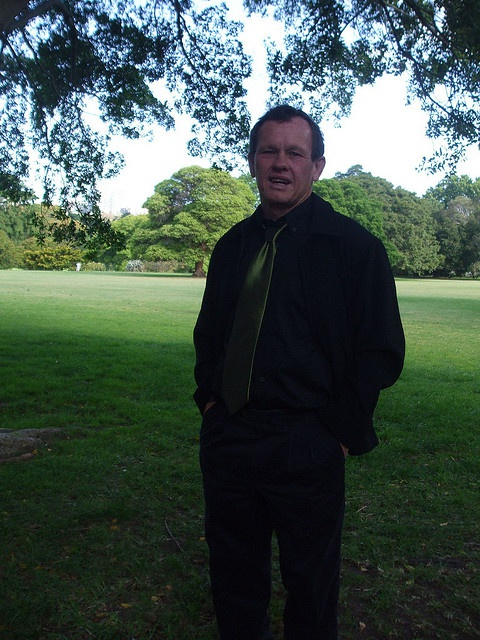Describe the objects in this image and their specific colors. I can see people in black and purple tones and tie in black and darkgreen tones in this image. 